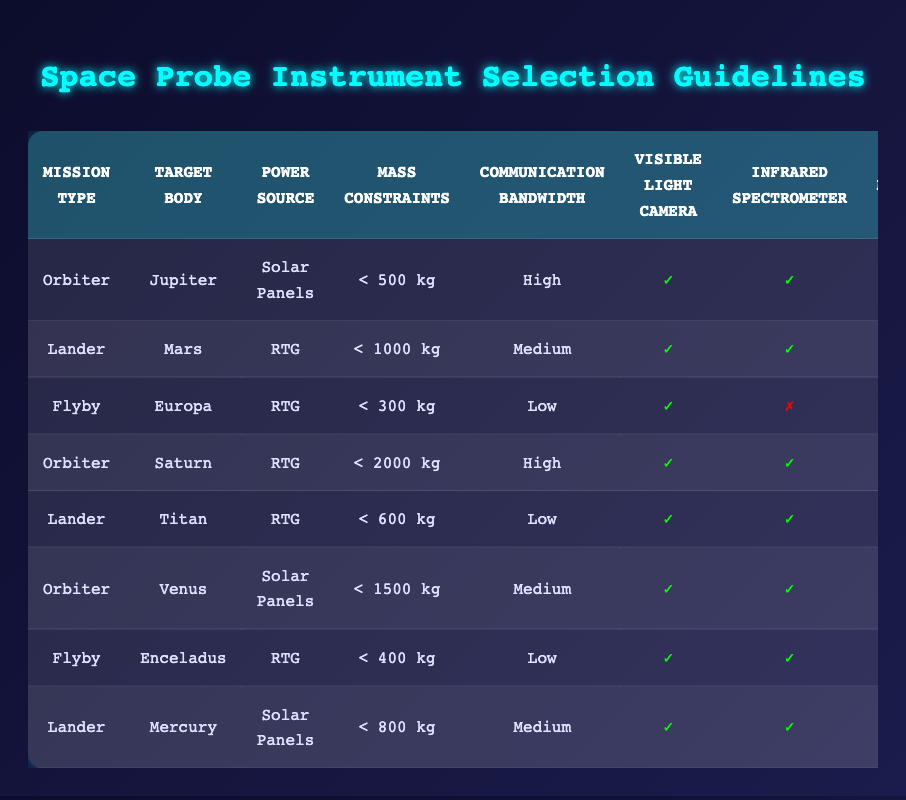What instruments are recommended for an orbiter mission to Jupiter with solar panels? In the table, under the row for "Orbiter" and "Jupiter" with "Solar Panels", the instruments highlighted as included are the Visible Light Camera, Infrared Spectrometer, Magnetometer, and Radio Science Instrument. The Mass Spectrometer and Radar Sounder are not included.
Answer: Visible Light Camera, Infrared Spectrometer, Magnetometer, Radio Science Instrument Does a lander mission to Mars include a magnetometer? Referring to the row for "Lander" and "Mars", it shows that the Magnetometer is marked as not included (✗). Therefore, the answer is no.
Answer: No Which type of mission has the highest number of recommended instruments? Looking at the row for the "Orbiter" mission to "Saturn", it includes all six instruments, which is the maximum number available. Other missions have fewer instruments included.
Answer: Orbiter to Saturn What is the total number of included instruments for a flyby mission to Europa? In the row for the "Flyby" mission to "Europa", the included instruments are the Visible Light Camera, Magnetometer, and Radio Science Instrument. That's a total of three instruments included.
Answer: 3 Is it true that both the lander to Mars and the lander to Titan include the Infrared Spectrometer? Checking the rows for both "Lander" missions, the Mars mission includes the Infrared Spectrometer (✓), but the Titan mission also includes it (✓). Thus, it is true for both missions.
Answer: Yes Which mission type with an RTG power source and low communication bandwidth includes the highest mass constraint? Reviewing the table, the "Flyby" mission to "Enceladus" has a mass constraint of less than 400 kg compared to the "Flyby" mission to "Europa" with less than 300 kg. Thus, the answer is that it is the Flyby to "Enceladus".
Answer: Flyby to Enceladus How many lander missions are included in the table? By examining the entries, there are three lander missions: Mars, Titan, and Mercury. Therefore, a total of three lander missions are listed.
Answer: 3 Are solar panels used in the mission to Mercury? In the row for the "Lander" mission to "Mercury", it shows that solar panels are indeed the power source used, hence the answer is yes.
Answer: Yes 